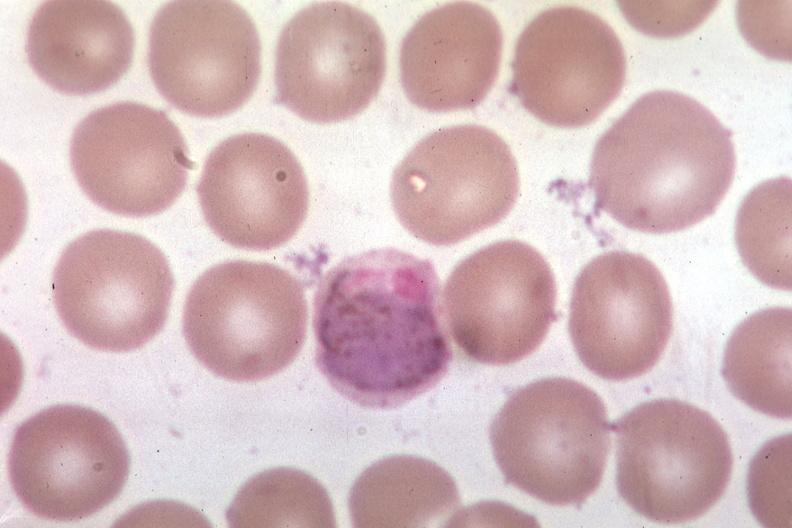s polysplenia present?
Answer the question using a single word or phrase. No 